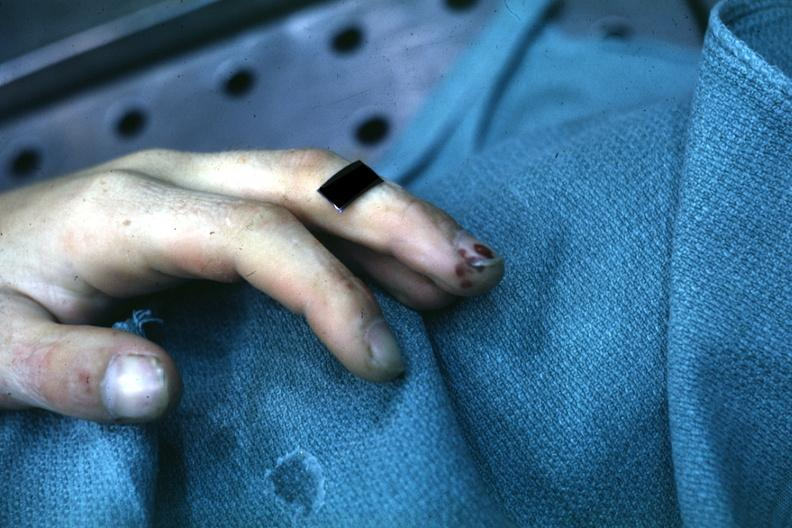what is lesions shown?
Answer the question using a single word or phrase. On index finger staphylococcus 